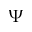<formula> <loc_0><loc_0><loc_500><loc_500>\Psi</formula> 